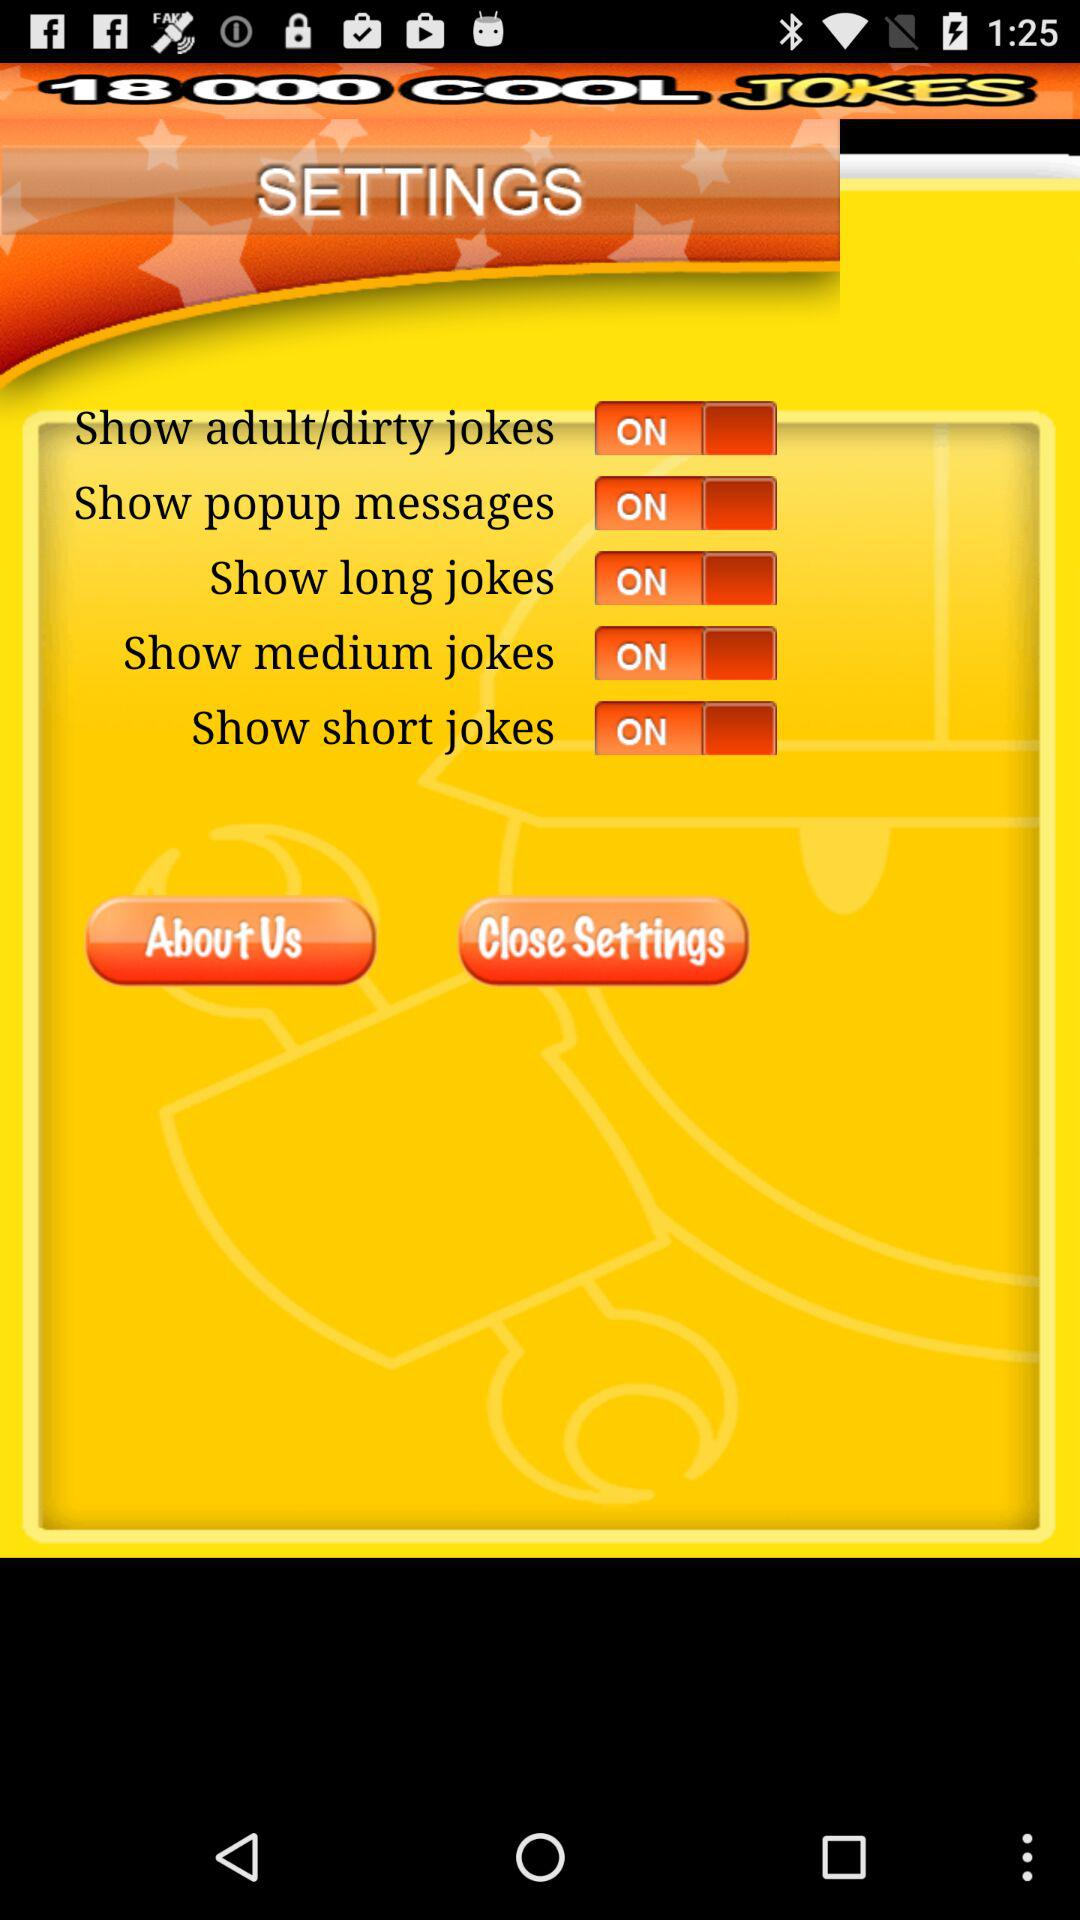What is the current status of the "Show popup messages" setting? The current status is "on". 